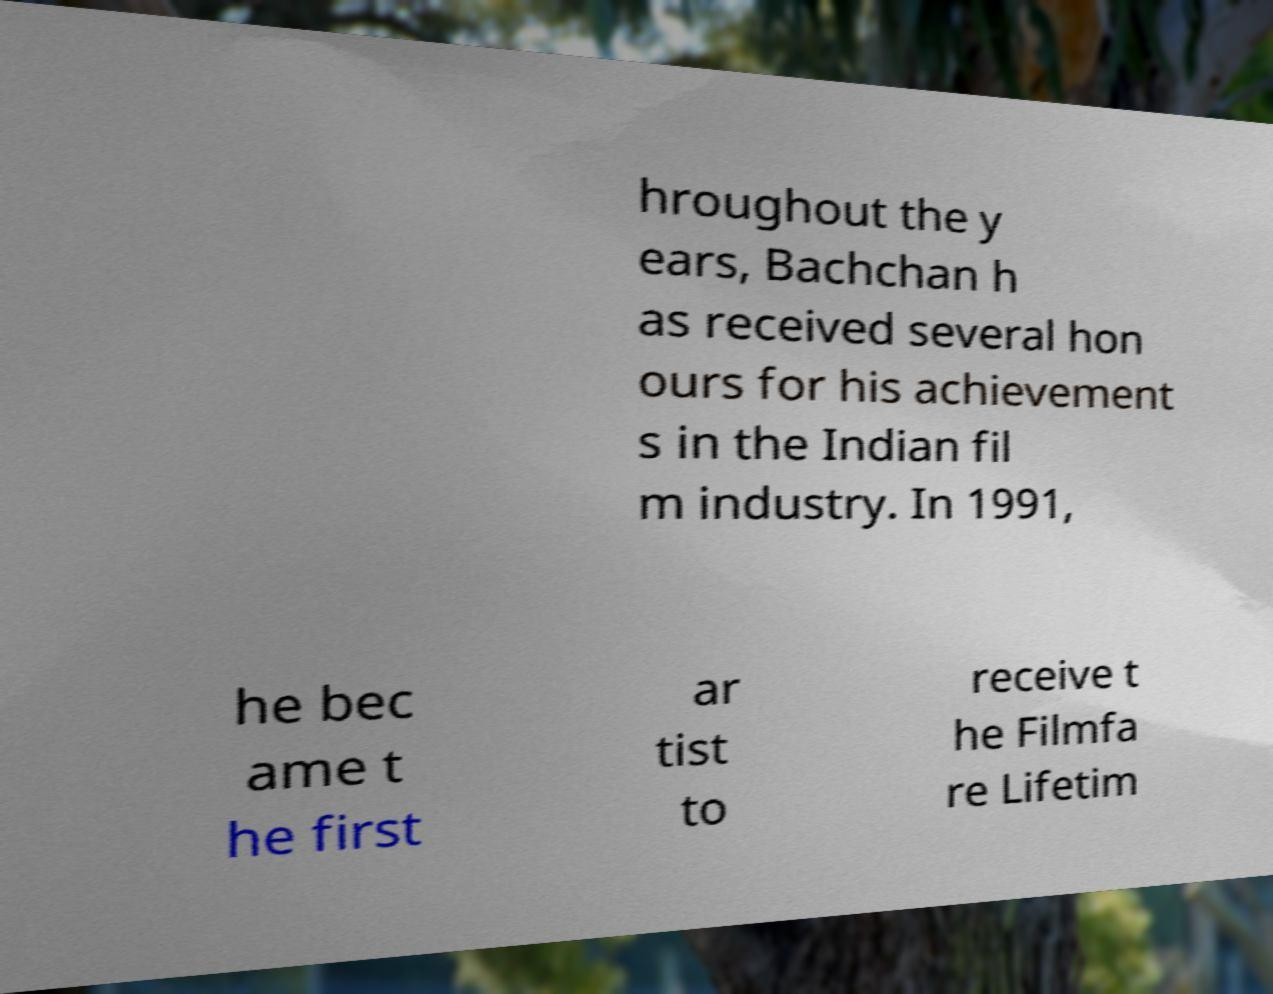Please identify and transcribe the text found in this image. hroughout the y ears, Bachchan h as received several hon ours for his achievement s in the Indian fil m industry. In 1991, he bec ame t he first ar tist to receive t he Filmfa re Lifetim 